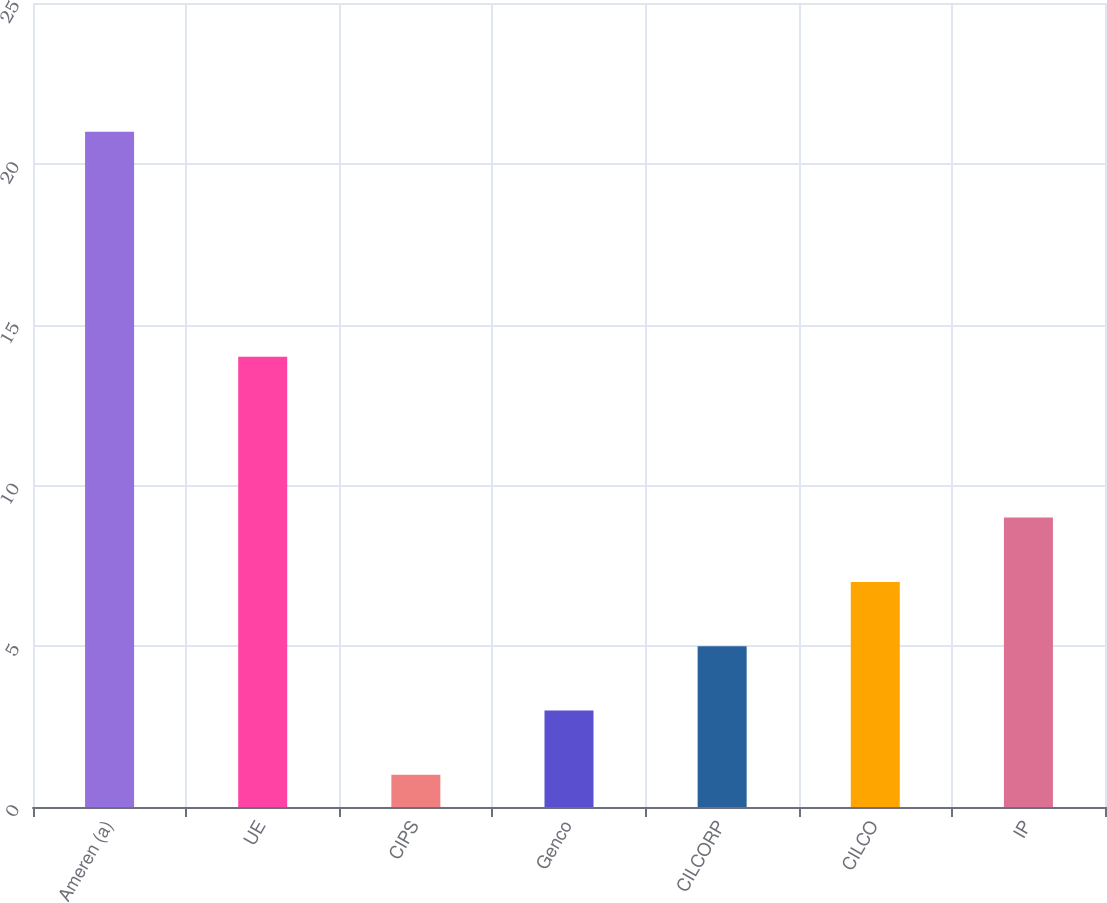Convert chart to OTSL. <chart><loc_0><loc_0><loc_500><loc_500><bar_chart><fcel>Ameren (a)<fcel>UE<fcel>CIPS<fcel>Genco<fcel>CILCORP<fcel>CILCO<fcel>IP<nl><fcel>21<fcel>14<fcel>1<fcel>3<fcel>5<fcel>7<fcel>9<nl></chart> 